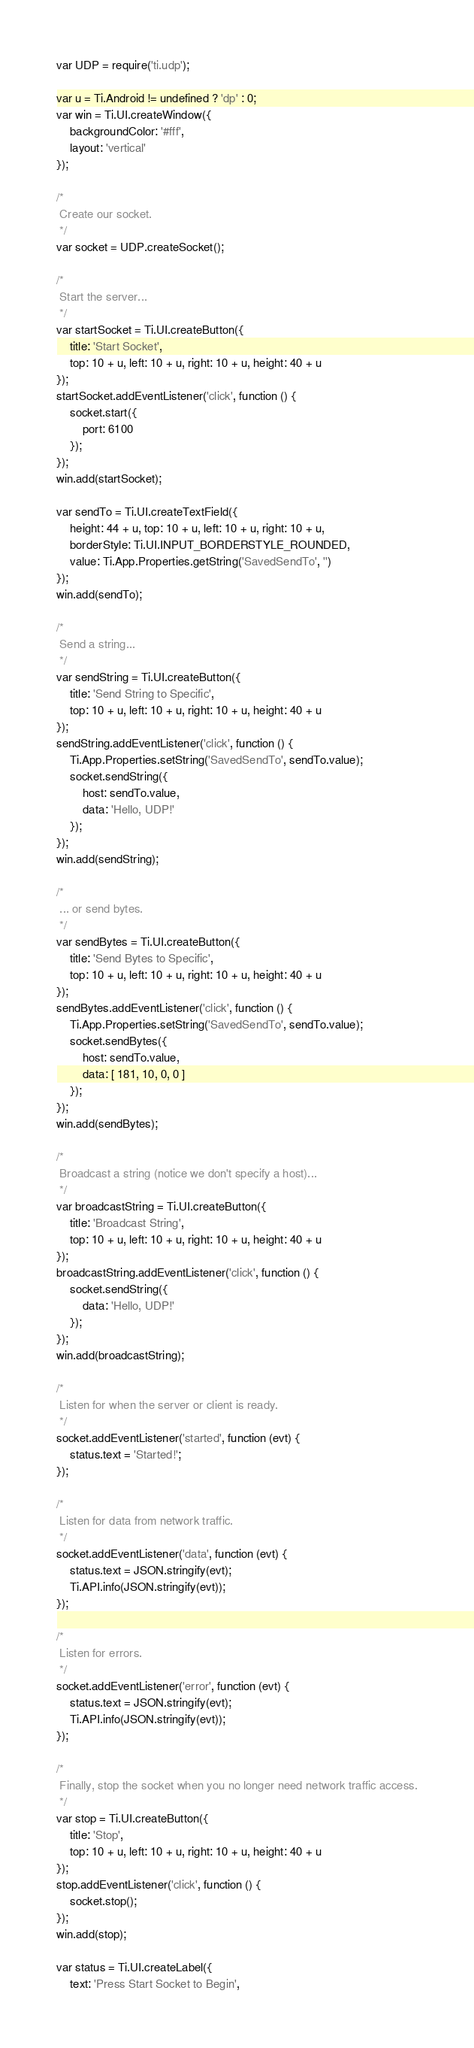<code> <loc_0><loc_0><loc_500><loc_500><_JavaScript_>var UDP = require('ti.udp');

var u = Ti.Android != undefined ? 'dp' : 0;
var win = Ti.UI.createWindow({
    backgroundColor: '#fff',
    layout: 'vertical'
});

/*
 Create our socket. 
 */
var socket = UDP.createSocket();

/*
 Start the server...
 */
var startSocket = Ti.UI.createButton({
    title: 'Start Socket',
    top: 10 + u, left: 10 + u, right: 10 + u, height: 40 + u
});
startSocket.addEventListener('click', function () {
    socket.start({
        port: 6100
    });
});
win.add(startSocket);

var sendTo = Ti.UI.createTextField({
    height: 44 + u, top: 10 + u, left: 10 + u, right: 10 + u,
    borderStyle: Ti.UI.INPUT_BORDERSTYLE_ROUNDED,
    value: Ti.App.Properties.getString('SavedSendTo', '')
});
win.add(sendTo);

/*
 Send a string...
 */
var sendString = Ti.UI.createButton({
    title: 'Send String to Specific',
    top: 10 + u, left: 10 + u, right: 10 + u, height: 40 + u
});
sendString.addEventListener('click', function () {
    Ti.App.Properties.setString('SavedSendTo', sendTo.value);
    socket.sendString({
        host: sendTo.value,
        data: 'Hello, UDP!'
    });
});
win.add(sendString);

/*
 ... or send bytes.
 */
var sendBytes = Ti.UI.createButton({
    title: 'Send Bytes to Specific',
    top: 10 + u, left: 10 + u, right: 10 + u, height: 40 + u
});
sendBytes.addEventListener('click', function () {
    Ti.App.Properties.setString('SavedSendTo', sendTo.value);
    socket.sendBytes({
        host: sendTo.value,
        data: [ 181, 10, 0, 0 ]
    });
});
win.add(sendBytes);

/*
 Broadcast a string (notice we don't specify a host)...
 */
var broadcastString = Ti.UI.createButton({
    title: 'Broadcast String',
    top: 10 + u, left: 10 + u, right: 10 + u, height: 40 + u
});
broadcastString.addEventListener('click', function () {
    socket.sendString({
        data: 'Hello, UDP!'
    });
});
win.add(broadcastString);

/*
 Listen for when the server or client is ready.
 */
socket.addEventListener('started', function (evt) {
    status.text = 'Started!';
});

/*
 Listen for data from network traffic.
 */
socket.addEventListener('data', function (evt) {
    status.text = JSON.stringify(evt);
    Ti.API.info(JSON.stringify(evt));
});

/*
 Listen for errors.
 */
socket.addEventListener('error', function (evt) {
    status.text = JSON.stringify(evt);
    Ti.API.info(JSON.stringify(evt));
});

/*
 Finally, stop the socket when you no longer need network traffic access.
 */
var stop = Ti.UI.createButton({
    title: 'Stop',
    top: 10 + u, left: 10 + u, right: 10 + u, height: 40 + u
});
stop.addEventListener('click', function () {
    socket.stop();
});
win.add(stop);

var status = Ti.UI.createLabel({
    text: 'Press Start Socket to Begin',</code> 